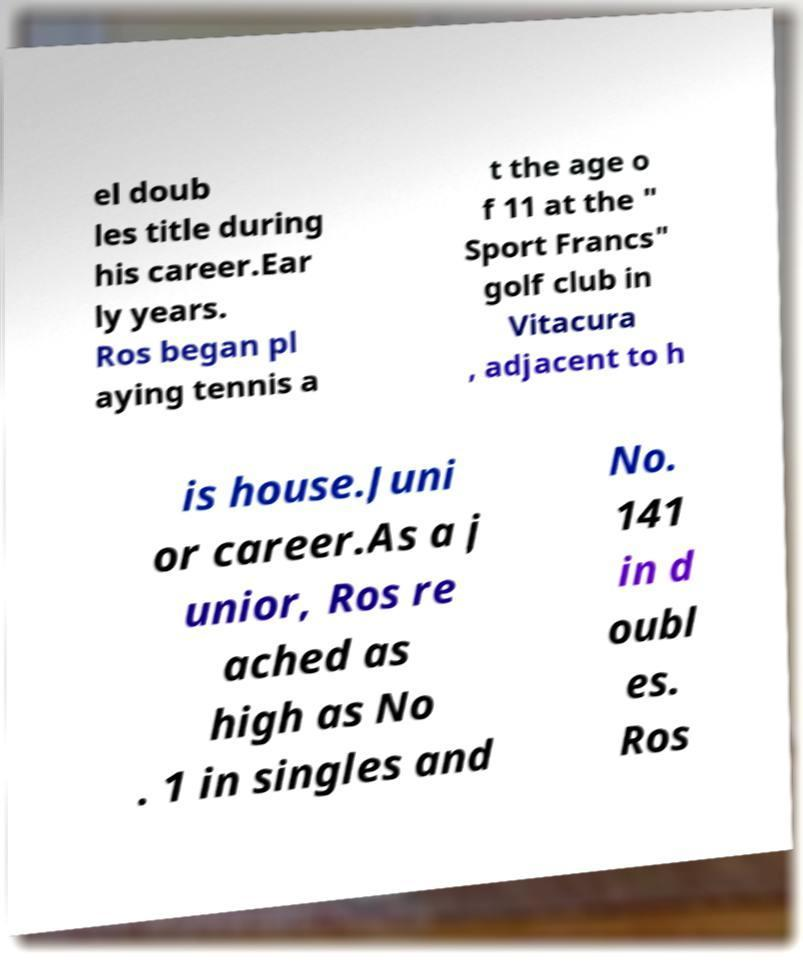For documentation purposes, I need the text within this image transcribed. Could you provide that? el doub les title during his career.Ear ly years. Ros began pl aying tennis a t the age o f 11 at the " Sport Francs" golf club in Vitacura , adjacent to h is house.Juni or career.As a j unior, Ros re ached as high as No . 1 in singles and No. 141 in d oubl es. Ros 